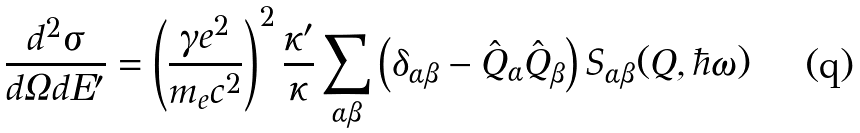Convert formula to latex. <formula><loc_0><loc_0><loc_500><loc_500>\frac { d ^ { 2 } \sigma } { d \Omega d E ^ { \prime } } = \left ( \frac { \gamma e ^ { 2 } } { m _ { e } c ^ { 2 } } \right ) ^ { 2 } \frac { \kappa ^ { \prime } } { \kappa } \sum _ { \alpha \beta } \left ( \delta _ { \alpha \beta } - \hat { Q } _ { \alpha } \hat { Q } _ { \beta } \right ) S _ { \alpha \beta } ( { Q } , \hbar { \omega } )</formula> 